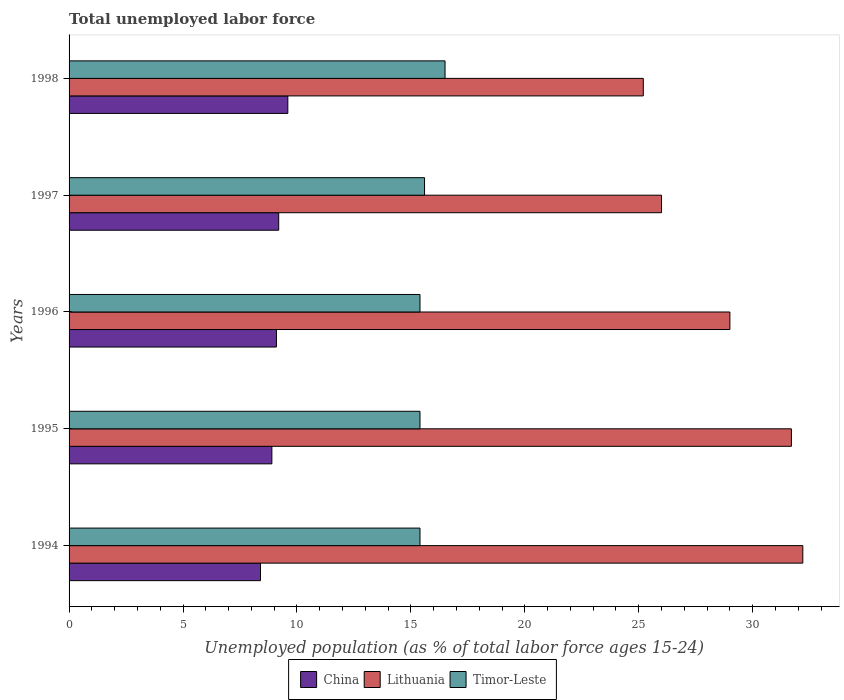How many different coloured bars are there?
Offer a very short reply. 3. Are the number of bars per tick equal to the number of legend labels?
Provide a succinct answer. Yes. How many bars are there on the 3rd tick from the top?
Provide a succinct answer. 3. Across all years, what is the maximum percentage of unemployed population in in Lithuania?
Provide a short and direct response. 32.2. Across all years, what is the minimum percentage of unemployed population in in China?
Ensure brevity in your answer.  8.4. In which year was the percentage of unemployed population in in China maximum?
Make the answer very short. 1998. In which year was the percentage of unemployed population in in China minimum?
Ensure brevity in your answer.  1994. What is the total percentage of unemployed population in in Timor-Leste in the graph?
Make the answer very short. 78.3. What is the difference between the percentage of unemployed population in in China in 1994 and that in 1997?
Your response must be concise. -0.8. What is the difference between the percentage of unemployed population in in Lithuania in 1996 and the percentage of unemployed population in in Timor-Leste in 1997?
Your answer should be compact. 13.4. What is the average percentage of unemployed population in in Lithuania per year?
Provide a short and direct response. 28.82. In the year 1994, what is the difference between the percentage of unemployed population in in Lithuania and percentage of unemployed population in in China?
Offer a terse response. 23.8. What is the ratio of the percentage of unemployed population in in Lithuania in 1994 to that in 1997?
Your response must be concise. 1.24. Is the percentage of unemployed population in in Lithuania in 1994 less than that in 1996?
Provide a succinct answer. No. What is the difference between the highest and the second highest percentage of unemployed population in in China?
Give a very brief answer. 0.4. What is the difference between the highest and the lowest percentage of unemployed population in in China?
Give a very brief answer. 1.2. In how many years, is the percentage of unemployed population in in Lithuania greater than the average percentage of unemployed population in in Lithuania taken over all years?
Give a very brief answer. 3. What does the 1st bar from the top in 1995 represents?
Provide a short and direct response. Timor-Leste. What does the 2nd bar from the bottom in 1997 represents?
Ensure brevity in your answer.  Lithuania. How many bars are there?
Offer a very short reply. 15. How many years are there in the graph?
Give a very brief answer. 5. What is the difference between two consecutive major ticks on the X-axis?
Make the answer very short. 5. Are the values on the major ticks of X-axis written in scientific E-notation?
Give a very brief answer. No. Does the graph contain any zero values?
Offer a terse response. No. What is the title of the graph?
Make the answer very short. Total unemployed labor force. Does "St. Vincent and the Grenadines" appear as one of the legend labels in the graph?
Provide a succinct answer. No. What is the label or title of the X-axis?
Your answer should be very brief. Unemployed population (as % of total labor force ages 15-24). What is the label or title of the Y-axis?
Give a very brief answer. Years. What is the Unemployed population (as % of total labor force ages 15-24) in China in 1994?
Provide a succinct answer. 8.4. What is the Unemployed population (as % of total labor force ages 15-24) of Lithuania in 1994?
Offer a very short reply. 32.2. What is the Unemployed population (as % of total labor force ages 15-24) of Timor-Leste in 1994?
Your answer should be very brief. 15.4. What is the Unemployed population (as % of total labor force ages 15-24) of China in 1995?
Your answer should be very brief. 8.9. What is the Unemployed population (as % of total labor force ages 15-24) of Lithuania in 1995?
Your answer should be very brief. 31.7. What is the Unemployed population (as % of total labor force ages 15-24) in Timor-Leste in 1995?
Offer a very short reply. 15.4. What is the Unemployed population (as % of total labor force ages 15-24) of China in 1996?
Provide a short and direct response. 9.1. What is the Unemployed population (as % of total labor force ages 15-24) in Timor-Leste in 1996?
Provide a succinct answer. 15.4. What is the Unemployed population (as % of total labor force ages 15-24) in China in 1997?
Provide a short and direct response. 9.2. What is the Unemployed population (as % of total labor force ages 15-24) in Lithuania in 1997?
Make the answer very short. 26. What is the Unemployed population (as % of total labor force ages 15-24) of Timor-Leste in 1997?
Your answer should be compact. 15.6. What is the Unemployed population (as % of total labor force ages 15-24) in China in 1998?
Offer a terse response. 9.6. What is the Unemployed population (as % of total labor force ages 15-24) in Lithuania in 1998?
Provide a succinct answer. 25.2. Across all years, what is the maximum Unemployed population (as % of total labor force ages 15-24) in China?
Keep it short and to the point. 9.6. Across all years, what is the maximum Unemployed population (as % of total labor force ages 15-24) in Lithuania?
Your answer should be very brief. 32.2. Across all years, what is the maximum Unemployed population (as % of total labor force ages 15-24) of Timor-Leste?
Offer a very short reply. 16.5. Across all years, what is the minimum Unemployed population (as % of total labor force ages 15-24) of China?
Keep it short and to the point. 8.4. Across all years, what is the minimum Unemployed population (as % of total labor force ages 15-24) of Lithuania?
Offer a very short reply. 25.2. Across all years, what is the minimum Unemployed population (as % of total labor force ages 15-24) in Timor-Leste?
Keep it short and to the point. 15.4. What is the total Unemployed population (as % of total labor force ages 15-24) of China in the graph?
Make the answer very short. 45.2. What is the total Unemployed population (as % of total labor force ages 15-24) in Lithuania in the graph?
Keep it short and to the point. 144.1. What is the total Unemployed population (as % of total labor force ages 15-24) in Timor-Leste in the graph?
Your response must be concise. 78.3. What is the difference between the Unemployed population (as % of total labor force ages 15-24) of China in 1994 and that in 1995?
Your response must be concise. -0.5. What is the difference between the Unemployed population (as % of total labor force ages 15-24) of Timor-Leste in 1994 and that in 1995?
Your answer should be very brief. 0. What is the difference between the Unemployed population (as % of total labor force ages 15-24) in Timor-Leste in 1994 and that in 1996?
Give a very brief answer. 0. What is the difference between the Unemployed population (as % of total labor force ages 15-24) in China in 1994 and that in 1997?
Provide a succinct answer. -0.8. What is the difference between the Unemployed population (as % of total labor force ages 15-24) in Timor-Leste in 1994 and that in 1998?
Your answer should be compact. -1.1. What is the difference between the Unemployed population (as % of total labor force ages 15-24) of Lithuania in 1995 and that in 1996?
Provide a short and direct response. 2.7. What is the difference between the Unemployed population (as % of total labor force ages 15-24) of China in 1995 and that in 1998?
Provide a succinct answer. -0.7. What is the difference between the Unemployed population (as % of total labor force ages 15-24) in Lithuania in 1995 and that in 1998?
Your answer should be compact. 6.5. What is the difference between the Unemployed population (as % of total labor force ages 15-24) of Lithuania in 1996 and that in 1997?
Ensure brevity in your answer.  3. What is the difference between the Unemployed population (as % of total labor force ages 15-24) of China in 1996 and that in 1998?
Your response must be concise. -0.5. What is the difference between the Unemployed population (as % of total labor force ages 15-24) in Lithuania in 1996 and that in 1998?
Give a very brief answer. 3.8. What is the difference between the Unemployed population (as % of total labor force ages 15-24) of Lithuania in 1997 and that in 1998?
Make the answer very short. 0.8. What is the difference between the Unemployed population (as % of total labor force ages 15-24) in Timor-Leste in 1997 and that in 1998?
Your answer should be very brief. -0.9. What is the difference between the Unemployed population (as % of total labor force ages 15-24) in China in 1994 and the Unemployed population (as % of total labor force ages 15-24) in Lithuania in 1995?
Provide a short and direct response. -23.3. What is the difference between the Unemployed population (as % of total labor force ages 15-24) of Lithuania in 1994 and the Unemployed population (as % of total labor force ages 15-24) of Timor-Leste in 1995?
Your response must be concise. 16.8. What is the difference between the Unemployed population (as % of total labor force ages 15-24) of China in 1994 and the Unemployed population (as % of total labor force ages 15-24) of Lithuania in 1996?
Provide a succinct answer. -20.6. What is the difference between the Unemployed population (as % of total labor force ages 15-24) in China in 1994 and the Unemployed population (as % of total labor force ages 15-24) in Timor-Leste in 1996?
Your answer should be very brief. -7. What is the difference between the Unemployed population (as % of total labor force ages 15-24) of Lithuania in 1994 and the Unemployed population (as % of total labor force ages 15-24) of Timor-Leste in 1996?
Your answer should be compact. 16.8. What is the difference between the Unemployed population (as % of total labor force ages 15-24) of China in 1994 and the Unemployed population (as % of total labor force ages 15-24) of Lithuania in 1997?
Offer a terse response. -17.6. What is the difference between the Unemployed population (as % of total labor force ages 15-24) in China in 1994 and the Unemployed population (as % of total labor force ages 15-24) in Timor-Leste in 1997?
Your response must be concise. -7.2. What is the difference between the Unemployed population (as % of total labor force ages 15-24) in Lithuania in 1994 and the Unemployed population (as % of total labor force ages 15-24) in Timor-Leste in 1997?
Ensure brevity in your answer.  16.6. What is the difference between the Unemployed population (as % of total labor force ages 15-24) in China in 1994 and the Unemployed population (as % of total labor force ages 15-24) in Lithuania in 1998?
Offer a very short reply. -16.8. What is the difference between the Unemployed population (as % of total labor force ages 15-24) in China in 1994 and the Unemployed population (as % of total labor force ages 15-24) in Timor-Leste in 1998?
Offer a terse response. -8.1. What is the difference between the Unemployed population (as % of total labor force ages 15-24) of Lithuania in 1994 and the Unemployed population (as % of total labor force ages 15-24) of Timor-Leste in 1998?
Provide a short and direct response. 15.7. What is the difference between the Unemployed population (as % of total labor force ages 15-24) in China in 1995 and the Unemployed population (as % of total labor force ages 15-24) in Lithuania in 1996?
Your answer should be compact. -20.1. What is the difference between the Unemployed population (as % of total labor force ages 15-24) in Lithuania in 1995 and the Unemployed population (as % of total labor force ages 15-24) in Timor-Leste in 1996?
Provide a succinct answer. 16.3. What is the difference between the Unemployed population (as % of total labor force ages 15-24) in China in 1995 and the Unemployed population (as % of total labor force ages 15-24) in Lithuania in 1997?
Give a very brief answer. -17.1. What is the difference between the Unemployed population (as % of total labor force ages 15-24) of China in 1995 and the Unemployed population (as % of total labor force ages 15-24) of Timor-Leste in 1997?
Give a very brief answer. -6.7. What is the difference between the Unemployed population (as % of total labor force ages 15-24) in China in 1995 and the Unemployed population (as % of total labor force ages 15-24) in Lithuania in 1998?
Make the answer very short. -16.3. What is the difference between the Unemployed population (as % of total labor force ages 15-24) in China in 1995 and the Unemployed population (as % of total labor force ages 15-24) in Timor-Leste in 1998?
Make the answer very short. -7.6. What is the difference between the Unemployed population (as % of total labor force ages 15-24) of China in 1996 and the Unemployed population (as % of total labor force ages 15-24) of Lithuania in 1997?
Offer a very short reply. -16.9. What is the difference between the Unemployed population (as % of total labor force ages 15-24) of China in 1996 and the Unemployed population (as % of total labor force ages 15-24) of Lithuania in 1998?
Give a very brief answer. -16.1. What is the difference between the Unemployed population (as % of total labor force ages 15-24) in Lithuania in 1996 and the Unemployed population (as % of total labor force ages 15-24) in Timor-Leste in 1998?
Make the answer very short. 12.5. What is the difference between the Unemployed population (as % of total labor force ages 15-24) in China in 1997 and the Unemployed population (as % of total labor force ages 15-24) in Lithuania in 1998?
Your response must be concise. -16. What is the difference between the Unemployed population (as % of total labor force ages 15-24) in China in 1997 and the Unemployed population (as % of total labor force ages 15-24) in Timor-Leste in 1998?
Make the answer very short. -7.3. What is the average Unemployed population (as % of total labor force ages 15-24) in China per year?
Keep it short and to the point. 9.04. What is the average Unemployed population (as % of total labor force ages 15-24) in Lithuania per year?
Give a very brief answer. 28.82. What is the average Unemployed population (as % of total labor force ages 15-24) of Timor-Leste per year?
Offer a very short reply. 15.66. In the year 1994, what is the difference between the Unemployed population (as % of total labor force ages 15-24) of China and Unemployed population (as % of total labor force ages 15-24) of Lithuania?
Give a very brief answer. -23.8. In the year 1995, what is the difference between the Unemployed population (as % of total labor force ages 15-24) of China and Unemployed population (as % of total labor force ages 15-24) of Lithuania?
Your response must be concise. -22.8. In the year 1996, what is the difference between the Unemployed population (as % of total labor force ages 15-24) in China and Unemployed population (as % of total labor force ages 15-24) in Lithuania?
Offer a terse response. -19.9. In the year 1996, what is the difference between the Unemployed population (as % of total labor force ages 15-24) of Lithuania and Unemployed population (as % of total labor force ages 15-24) of Timor-Leste?
Your answer should be very brief. 13.6. In the year 1997, what is the difference between the Unemployed population (as % of total labor force ages 15-24) in China and Unemployed population (as % of total labor force ages 15-24) in Lithuania?
Provide a succinct answer. -16.8. In the year 1998, what is the difference between the Unemployed population (as % of total labor force ages 15-24) of China and Unemployed population (as % of total labor force ages 15-24) of Lithuania?
Your response must be concise. -15.6. In the year 1998, what is the difference between the Unemployed population (as % of total labor force ages 15-24) of China and Unemployed population (as % of total labor force ages 15-24) of Timor-Leste?
Offer a terse response. -6.9. In the year 1998, what is the difference between the Unemployed population (as % of total labor force ages 15-24) of Lithuania and Unemployed population (as % of total labor force ages 15-24) of Timor-Leste?
Offer a very short reply. 8.7. What is the ratio of the Unemployed population (as % of total labor force ages 15-24) of China in 1994 to that in 1995?
Your response must be concise. 0.94. What is the ratio of the Unemployed population (as % of total labor force ages 15-24) of Lithuania in 1994 to that in 1995?
Your answer should be compact. 1.02. What is the ratio of the Unemployed population (as % of total labor force ages 15-24) in Timor-Leste in 1994 to that in 1995?
Offer a terse response. 1. What is the ratio of the Unemployed population (as % of total labor force ages 15-24) of China in 1994 to that in 1996?
Ensure brevity in your answer.  0.92. What is the ratio of the Unemployed population (as % of total labor force ages 15-24) in Lithuania in 1994 to that in 1996?
Keep it short and to the point. 1.11. What is the ratio of the Unemployed population (as % of total labor force ages 15-24) in Timor-Leste in 1994 to that in 1996?
Offer a very short reply. 1. What is the ratio of the Unemployed population (as % of total labor force ages 15-24) in Lithuania in 1994 to that in 1997?
Provide a succinct answer. 1.24. What is the ratio of the Unemployed population (as % of total labor force ages 15-24) in Timor-Leste in 1994 to that in 1997?
Ensure brevity in your answer.  0.99. What is the ratio of the Unemployed population (as % of total labor force ages 15-24) in China in 1994 to that in 1998?
Provide a succinct answer. 0.88. What is the ratio of the Unemployed population (as % of total labor force ages 15-24) in Lithuania in 1994 to that in 1998?
Provide a short and direct response. 1.28. What is the ratio of the Unemployed population (as % of total labor force ages 15-24) in Timor-Leste in 1994 to that in 1998?
Your answer should be compact. 0.93. What is the ratio of the Unemployed population (as % of total labor force ages 15-24) of China in 1995 to that in 1996?
Make the answer very short. 0.98. What is the ratio of the Unemployed population (as % of total labor force ages 15-24) of Lithuania in 1995 to that in 1996?
Your answer should be compact. 1.09. What is the ratio of the Unemployed population (as % of total labor force ages 15-24) of China in 1995 to that in 1997?
Make the answer very short. 0.97. What is the ratio of the Unemployed population (as % of total labor force ages 15-24) of Lithuania in 1995 to that in 1997?
Your response must be concise. 1.22. What is the ratio of the Unemployed population (as % of total labor force ages 15-24) in Timor-Leste in 1995 to that in 1997?
Provide a succinct answer. 0.99. What is the ratio of the Unemployed population (as % of total labor force ages 15-24) of China in 1995 to that in 1998?
Offer a terse response. 0.93. What is the ratio of the Unemployed population (as % of total labor force ages 15-24) of Lithuania in 1995 to that in 1998?
Offer a very short reply. 1.26. What is the ratio of the Unemployed population (as % of total labor force ages 15-24) in China in 1996 to that in 1997?
Your response must be concise. 0.99. What is the ratio of the Unemployed population (as % of total labor force ages 15-24) in Lithuania in 1996 to that in 1997?
Your answer should be very brief. 1.12. What is the ratio of the Unemployed population (as % of total labor force ages 15-24) in Timor-Leste in 1996 to that in 1997?
Your answer should be compact. 0.99. What is the ratio of the Unemployed population (as % of total labor force ages 15-24) of China in 1996 to that in 1998?
Offer a very short reply. 0.95. What is the ratio of the Unemployed population (as % of total labor force ages 15-24) of Lithuania in 1996 to that in 1998?
Give a very brief answer. 1.15. What is the ratio of the Unemployed population (as % of total labor force ages 15-24) in China in 1997 to that in 1998?
Your response must be concise. 0.96. What is the ratio of the Unemployed population (as % of total labor force ages 15-24) of Lithuania in 1997 to that in 1998?
Keep it short and to the point. 1.03. What is the ratio of the Unemployed population (as % of total labor force ages 15-24) in Timor-Leste in 1997 to that in 1998?
Your answer should be very brief. 0.95. What is the difference between the highest and the second highest Unemployed population (as % of total labor force ages 15-24) in China?
Offer a very short reply. 0.4. What is the difference between the highest and the lowest Unemployed population (as % of total labor force ages 15-24) of Timor-Leste?
Your answer should be compact. 1.1. 